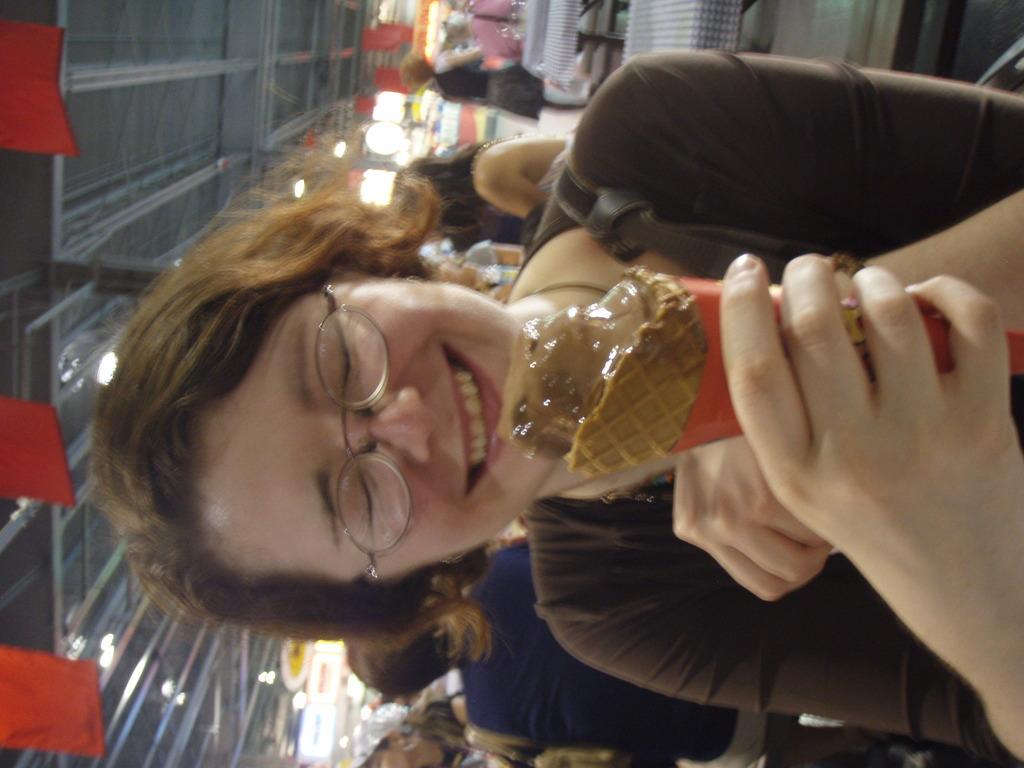What is the person in the image doing? The person in the image is smiling and holding an ice cream. Can you describe the setting of the image? There is a group of people, tables, banners, and lights visible in the image. What might the banners be used for? The banners could be used for decoration or to convey a message. How many people are in the image? There is a group of people in the image, but the exact number is not specified. What type of underwear is the person wearing in the image? There is no information about the person's underwear in the image, and therefore it cannot be determined. 